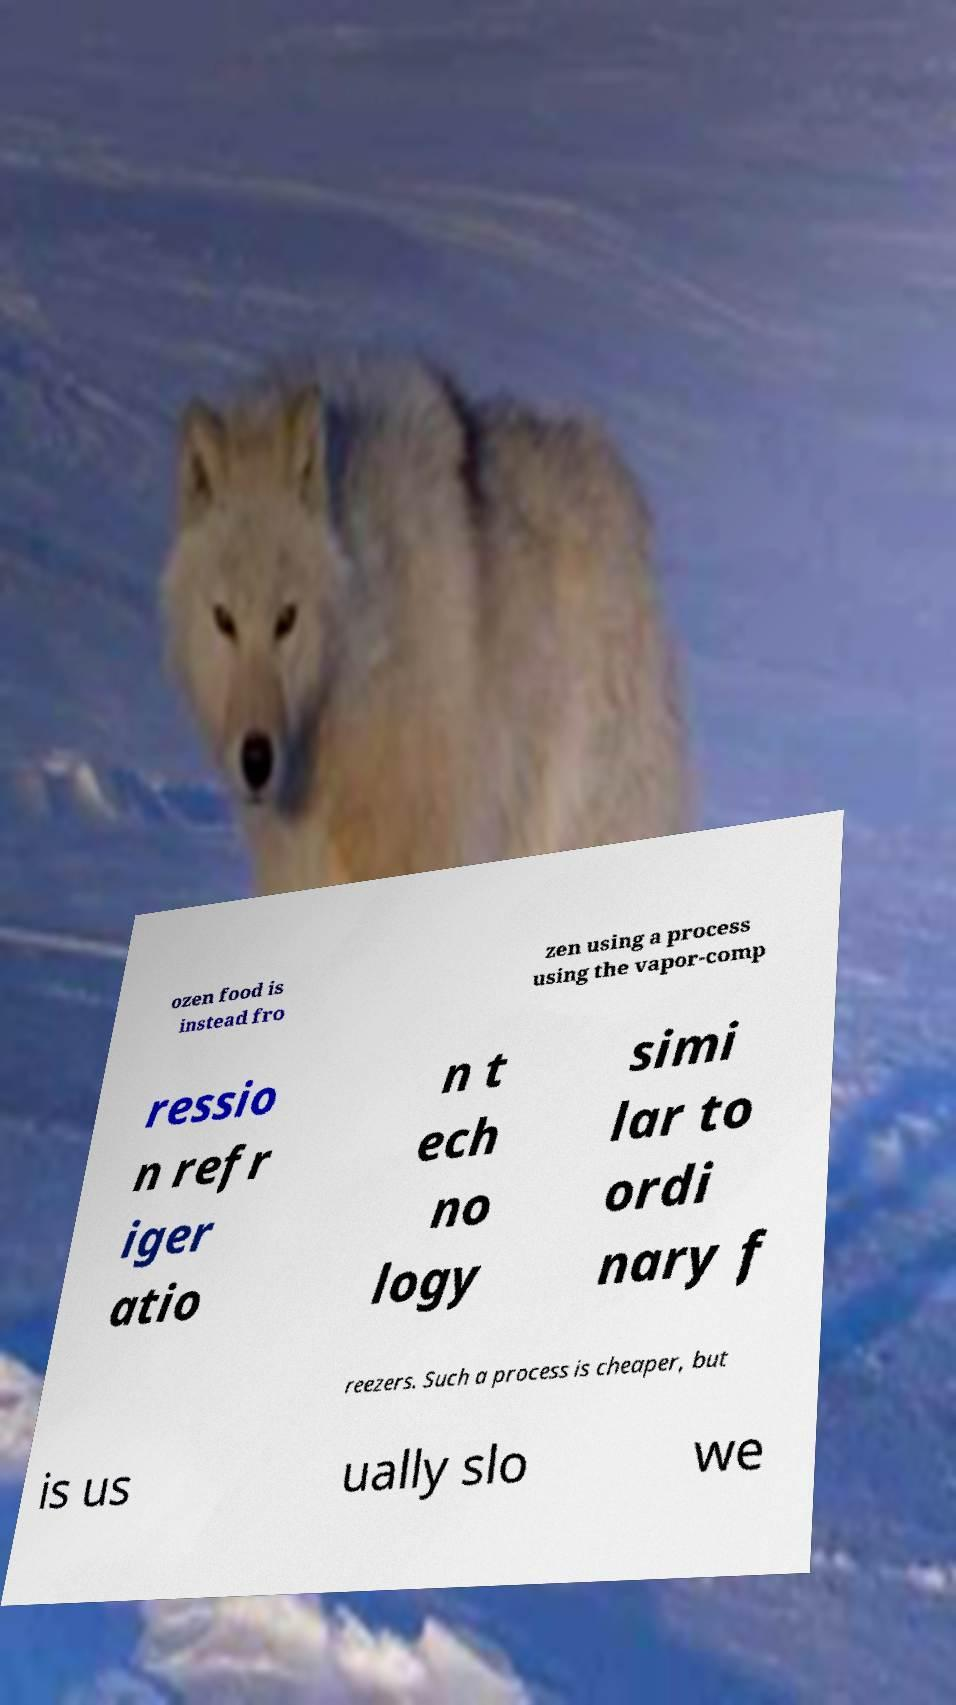Could you assist in decoding the text presented in this image and type it out clearly? ozen food is instead fro zen using a process using the vapor-comp ressio n refr iger atio n t ech no logy simi lar to ordi nary f reezers. Such a process is cheaper, but is us ually slo we 